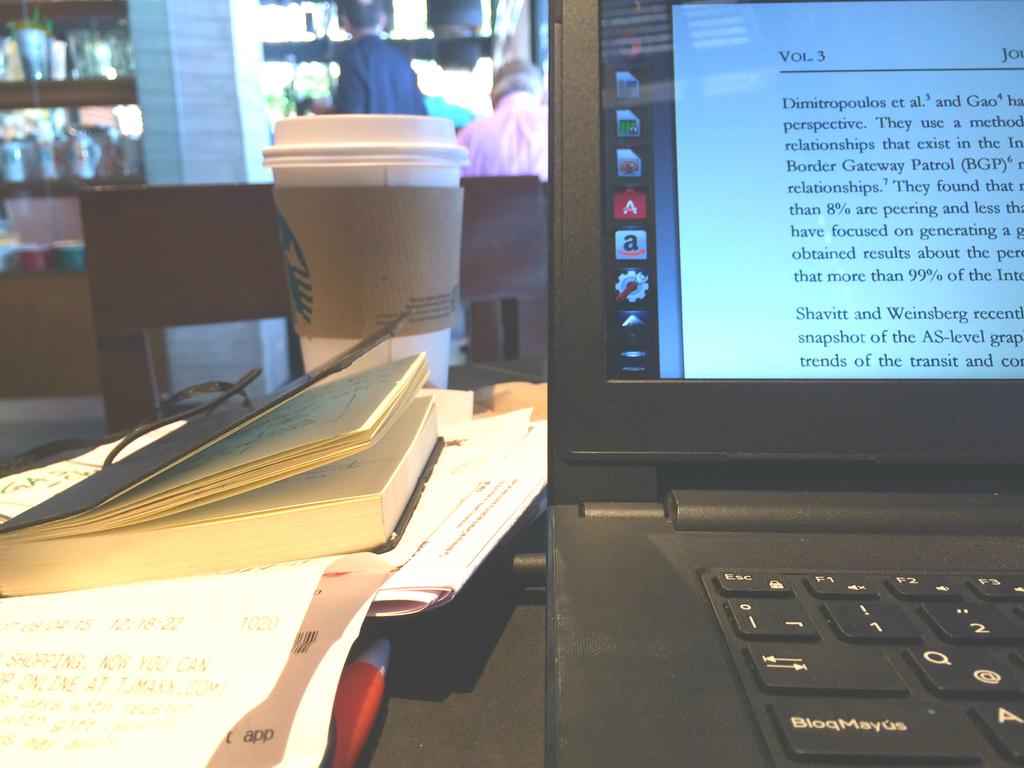What is the first percentage in the paragraph?
Keep it short and to the point. 8%. 